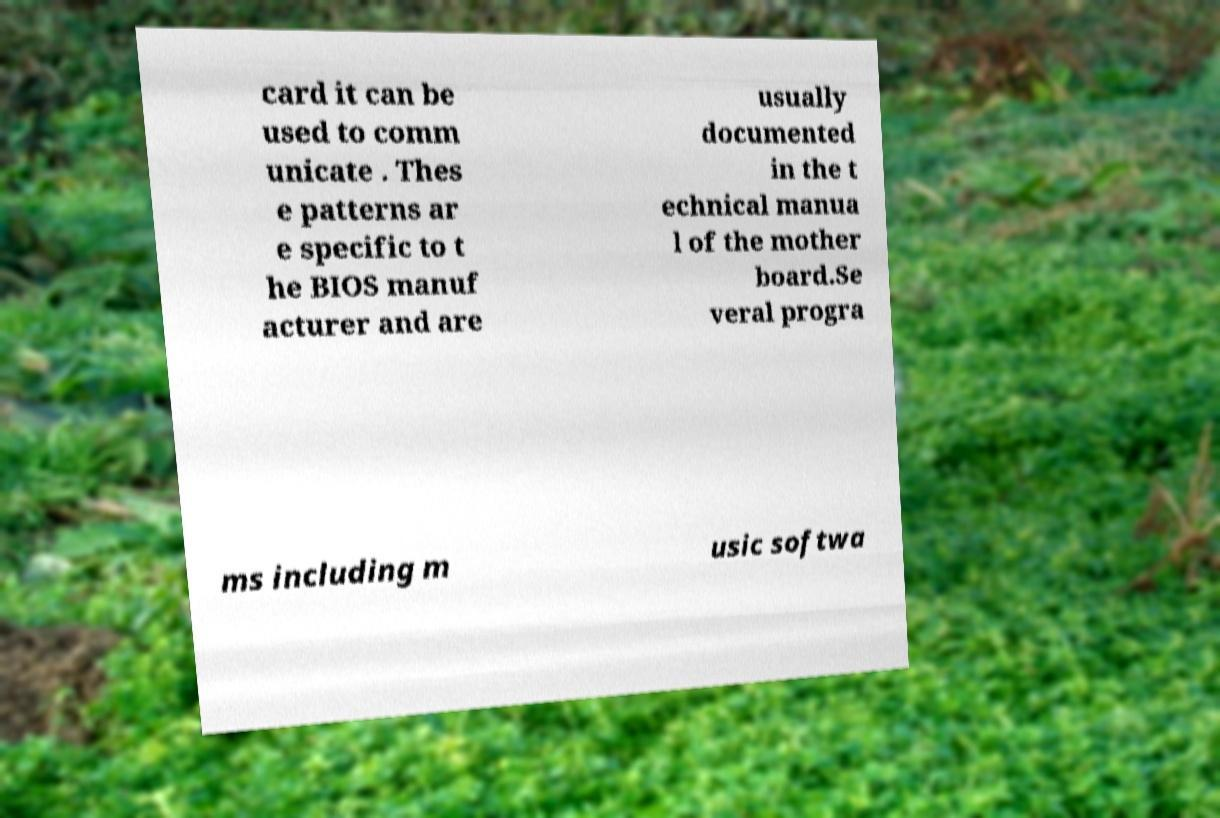I need the written content from this picture converted into text. Can you do that? card it can be used to comm unicate . Thes e patterns ar e specific to t he BIOS manuf acturer and are usually documented in the t echnical manua l of the mother board.Se veral progra ms including m usic softwa 